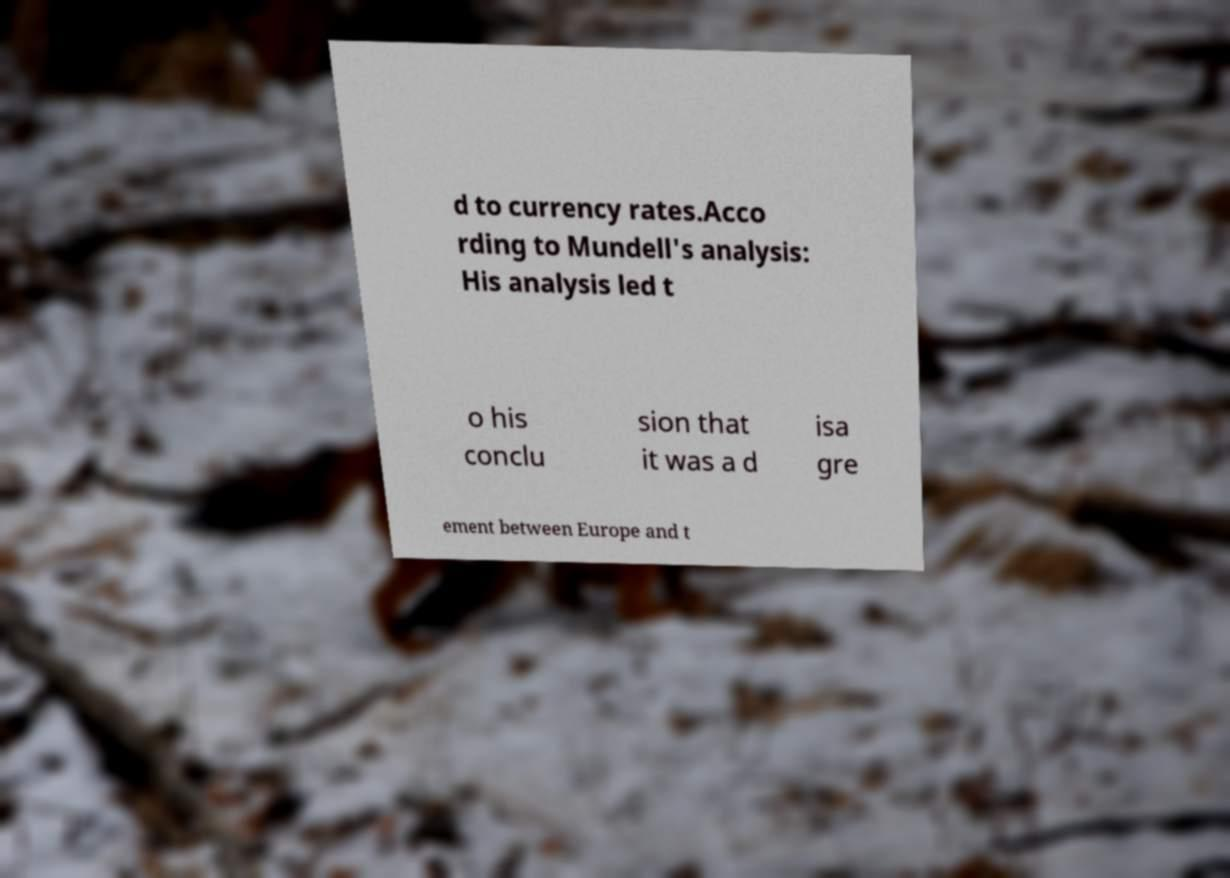Can you read and provide the text displayed in the image?This photo seems to have some interesting text. Can you extract and type it out for me? d to currency rates.Acco rding to Mundell's analysis: His analysis led t o his conclu sion that it was a d isa gre ement between Europe and t 